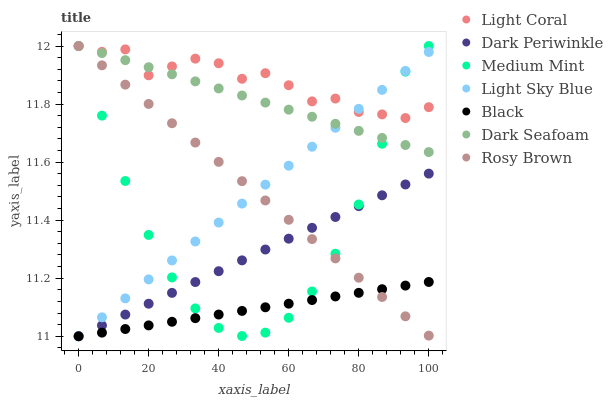Does Black have the minimum area under the curve?
Answer yes or no. Yes. Does Light Coral have the maximum area under the curve?
Answer yes or no. Yes. Does Rosy Brown have the minimum area under the curve?
Answer yes or no. No. Does Rosy Brown have the maximum area under the curve?
Answer yes or no. No. Is Dark Periwinkle the smoothest?
Answer yes or no. Yes. Is Light Coral the roughest?
Answer yes or no. Yes. Is Rosy Brown the smoothest?
Answer yes or no. No. Is Rosy Brown the roughest?
Answer yes or no. No. Does Light Sky Blue have the lowest value?
Answer yes or no. Yes. Does Rosy Brown have the lowest value?
Answer yes or no. No. Does Dark Seafoam have the highest value?
Answer yes or no. Yes. Does Light Sky Blue have the highest value?
Answer yes or no. No. Is Dark Periwinkle less than Dark Seafoam?
Answer yes or no. Yes. Is Dark Seafoam greater than Dark Periwinkle?
Answer yes or no. Yes. Does Medium Mint intersect Light Coral?
Answer yes or no. Yes. Is Medium Mint less than Light Coral?
Answer yes or no. No. Is Medium Mint greater than Light Coral?
Answer yes or no. No. Does Dark Periwinkle intersect Dark Seafoam?
Answer yes or no. No. 